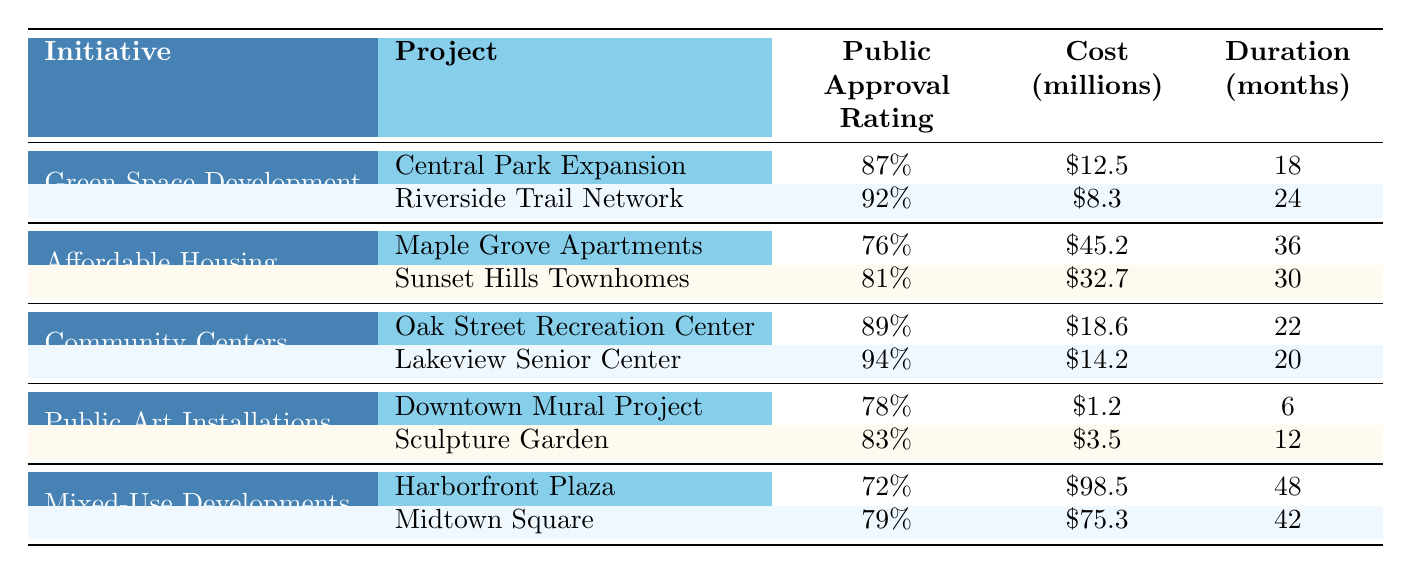What is the public approval rating for the "Lakeview Senior Center"? The rating is directly stated in the table next to the "Lakeview Senior Center" project, which indicates a public approval rating of 94%.
Answer: 94% Which project had the lowest public approval rating in the table? By reviewing the public approval ratings for all projects, the "Harborfront Plaza" has the lowest rating at 72%.
Answer: Harborfront Plaza What is the total cost of the "Green Space Development" initiatives? Adding the costs of both projects under "Green Space Development": \$12.5 million (Central Park Expansion) + \$8.3 million (Riverside Trail Network) = \$20.8 million.
Answer: \$20.8 million What is the average public approval rating for all community engagement initiatives? First, sum the public approval ratings: 87 + 92 + 76 + 81 + 89 + 94 + 78 + 83 + 72 + 79 = 922. Then divide by the total number of projects (10): 922 / 10 = 92.2.
Answer: 92.2% Which initiative has the highest average public approval rating? Calculate the average for each initiative: Green Space Development: (87 + 92) / 2 = 89.5; Affordable Housing: (76 + 81) / 2 = 78.5; Community Centers: (89 + 94) / 2 = 91.5; Public Art Installations: (78 + 83) / 2 = 80.5; Mixed-Use Developments: (72 + 79) / 2 = 75.5. The highest average is from Community Centers at 91.5.
Answer: Community Centers Is the cost of the "Sculpture Garden" initiative higher than that of the "Downtown Mural Project"? The cost of the "Sculpture Garden" is \$3.5 million and for the "Downtown Mural Project" is \$1.2 million. Since \$3.5 million is greater than \$1.2 million, the statement is true.
Answer: Yes How many months did it take to complete the "Midtown Square" project? The table directly lists the duration for "Midtown Square," which is 42 months.
Answer: 42 months What is the difference in public approval ratings between "Oak Street Recreation Center" and "Sunset Hills Townhomes"? The public approval rating of "Oak Street Recreation Center" is 89% and "Sunset Hills Townhomes" is 81%. The difference is 89 - 81 = 8%.
Answer: 8% Which initiative had the highest project cost and what was that cost? Reviewing the costs, "Harborfront Plaza" under Mixed-Use Developments has the highest cost of \$98.5 million.
Answer: \$98.5 million 